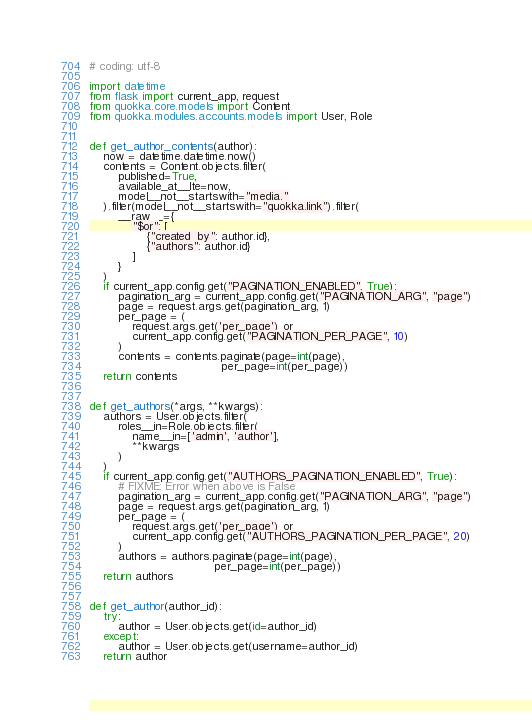Convert code to text. <code><loc_0><loc_0><loc_500><loc_500><_Python_># coding: utf-8

import datetime
from flask import current_app, request
from quokka.core.models import Content
from quokka.modules.accounts.models import User, Role


def get_author_contents(author):
    now = datetime.datetime.now()
    contents = Content.objects.filter(
        published=True,
        available_at__lte=now,
        model__not__startswith="media."
    ).filter(model__not__startswith="quokka.link").filter(
        __raw__={
            "$or": [
                {"created_by": author.id},
                {"authors": author.id}
            ]
        }
    )
    if current_app.config.get("PAGINATION_ENABLED", True):
        pagination_arg = current_app.config.get("PAGINATION_ARG", "page")
        page = request.args.get(pagination_arg, 1)
        per_page = (
            request.args.get('per_page') or
            current_app.config.get("PAGINATION_PER_PAGE", 10)
        )
        contents = contents.paginate(page=int(page),
                                     per_page=int(per_page))
    return contents


def get_authors(*args, **kwargs):
    authors = User.objects.filter(
        roles__in=Role.objects.filter(
            name__in=['admin', 'author'],
            **kwargs
        )
    )
    if current_app.config.get("AUTHORS_PAGINATION_ENABLED", True):
        # FIXME: Error when above is False
        pagination_arg = current_app.config.get("PAGINATION_ARG", "page")
        page = request.args.get(pagination_arg, 1)
        per_page = (
            request.args.get('per_page') or
            current_app.config.get("AUTHORS_PAGINATION_PER_PAGE", 20)
        )
        authors = authors.paginate(page=int(page),
                                   per_page=int(per_page))
    return authors


def get_author(author_id):
    try:
        author = User.objects.get(id=author_id)
    except:
        author = User.objects.get(username=author_id)
    return author
</code> 